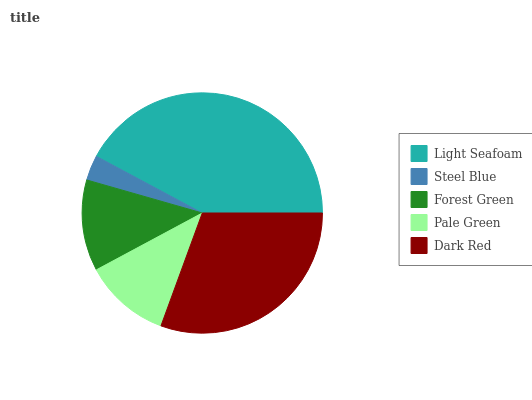Is Steel Blue the minimum?
Answer yes or no. Yes. Is Light Seafoam the maximum?
Answer yes or no. Yes. Is Forest Green the minimum?
Answer yes or no. No. Is Forest Green the maximum?
Answer yes or no. No. Is Forest Green greater than Steel Blue?
Answer yes or no. Yes. Is Steel Blue less than Forest Green?
Answer yes or no. Yes. Is Steel Blue greater than Forest Green?
Answer yes or no. No. Is Forest Green less than Steel Blue?
Answer yes or no. No. Is Forest Green the high median?
Answer yes or no. Yes. Is Forest Green the low median?
Answer yes or no. Yes. Is Light Seafoam the high median?
Answer yes or no. No. Is Steel Blue the low median?
Answer yes or no. No. 